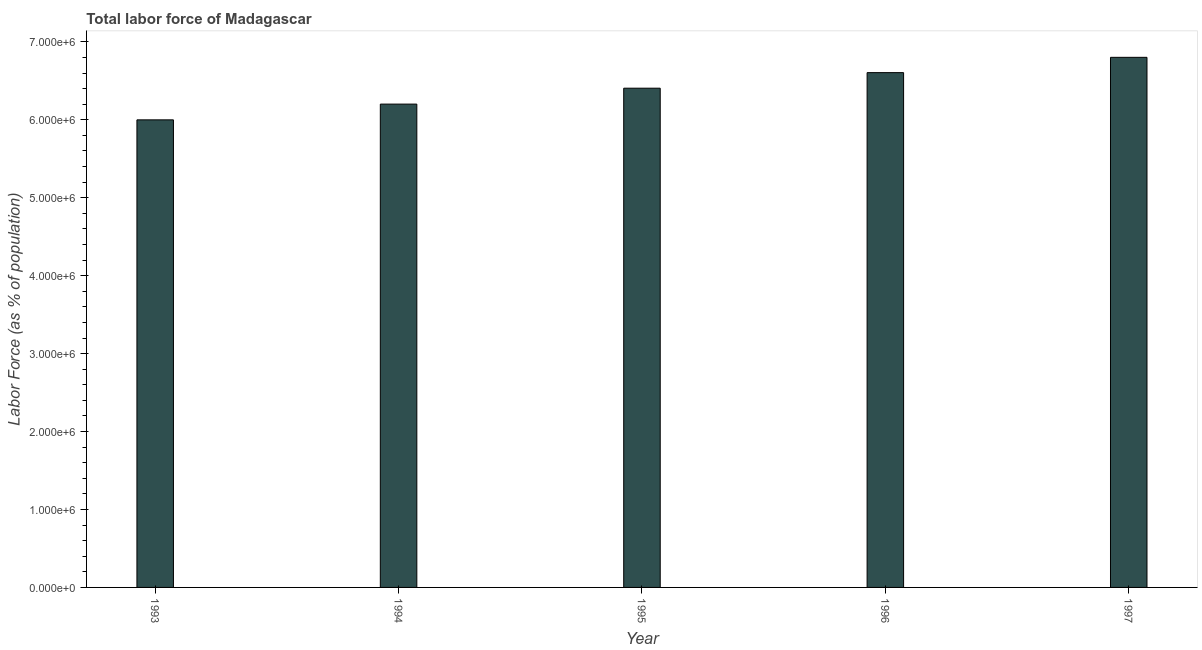What is the title of the graph?
Your answer should be very brief. Total labor force of Madagascar. What is the label or title of the Y-axis?
Ensure brevity in your answer.  Labor Force (as % of population). What is the total labor force in 1997?
Provide a succinct answer. 6.80e+06. Across all years, what is the maximum total labor force?
Your answer should be very brief. 6.80e+06. Across all years, what is the minimum total labor force?
Provide a succinct answer. 6.00e+06. In which year was the total labor force maximum?
Offer a very short reply. 1997. What is the sum of the total labor force?
Offer a terse response. 3.20e+07. What is the difference between the total labor force in 1993 and 1997?
Provide a short and direct response. -8.02e+05. What is the average total labor force per year?
Offer a very short reply. 6.40e+06. What is the median total labor force?
Your answer should be compact. 6.41e+06. Do a majority of the years between 1995 and 1994 (inclusive) have total labor force greater than 2600000 %?
Keep it short and to the point. No. What is the ratio of the total labor force in 1993 to that in 1995?
Make the answer very short. 0.94. Is the difference between the total labor force in 1993 and 1996 greater than the difference between any two years?
Your answer should be compact. No. What is the difference between the highest and the second highest total labor force?
Make the answer very short. 1.96e+05. What is the difference between the highest and the lowest total labor force?
Ensure brevity in your answer.  8.02e+05. In how many years, is the total labor force greater than the average total labor force taken over all years?
Your response must be concise. 3. How many years are there in the graph?
Keep it short and to the point. 5. Are the values on the major ticks of Y-axis written in scientific E-notation?
Provide a succinct answer. Yes. What is the Labor Force (as % of population) of 1993?
Provide a short and direct response. 6.00e+06. What is the Labor Force (as % of population) in 1994?
Offer a terse response. 6.20e+06. What is the Labor Force (as % of population) in 1995?
Your answer should be very brief. 6.41e+06. What is the Labor Force (as % of population) in 1996?
Keep it short and to the point. 6.61e+06. What is the Labor Force (as % of population) of 1997?
Your answer should be very brief. 6.80e+06. What is the difference between the Labor Force (as % of population) in 1993 and 1994?
Your answer should be compact. -2.02e+05. What is the difference between the Labor Force (as % of population) in 1993 and 1995?
Offer a very short reply. -4.06e+05. What is the difference between the Labor Force (as % of population) in 1993 and 1996?
Offer a very short reply. -6.06e+05. What is the difference between the Labor Force (as % of population) in 1993 and 1997?
Provide a succinct answer. -8.02e+05. What is the difference between the Labor Force (as % of population) in 1994 and 1995?
Ensure brevity in your answer.  -2.04e+05. What is the difference between the Labor Force (as % of population) in 1994 and 1996?
Keep it short and to the point. -4.04e+05. What is the difference between the Labor Force (as % of population) in 1994 and 1997?
Give a very brief answer. -6.00e+05. What is the difference between the Labor Force (as % of population) in 1995 and 1996?
Provide a short and direct response. -2.00e+05. What is the difference between the Labor Force (as % of population) in 1995 and 1997?
Your answer should be compact. -3.96e+05. What is the difference between the Labor Force (as % of population) in 1996 and 1997?
Ensure brevity in your answer.  -1.96e+05. What is the ratio of the Labor Force (as % of population) in 1993 to that in 1994?
Give a very brief answer. 0.97. What is the ratio of the Labor Force (as % of population) in 1993 to that in 1995?
Keep it short and to the point. 0.94. What is the ratio of the Labor Force (as % of population) in 1993 to that in 1996?
Your answer should be very brief. 0.91. What is the ratio of the Labor Force (as % of population) in 1993 to that in 1997?
Ensure brevity in your answer.  0.88. What is the ratio of the Labor Force (as % of population) in 1994 to that in 1996?
Keep it short and to the point. 0.94. What is the ratio of the Labor Force (as % of population) in 1994 to that in 1997?
Keep it short and to the point. 0.91. What is the ratio of the Labor Force (as % of population) in 1995 to that in 1997?
Your answer should be very brief. 0.94. What is the ratio of the Labor Force (as % of population) in 1996 to that in 1997?
Offer a very short reply. 0.97. 